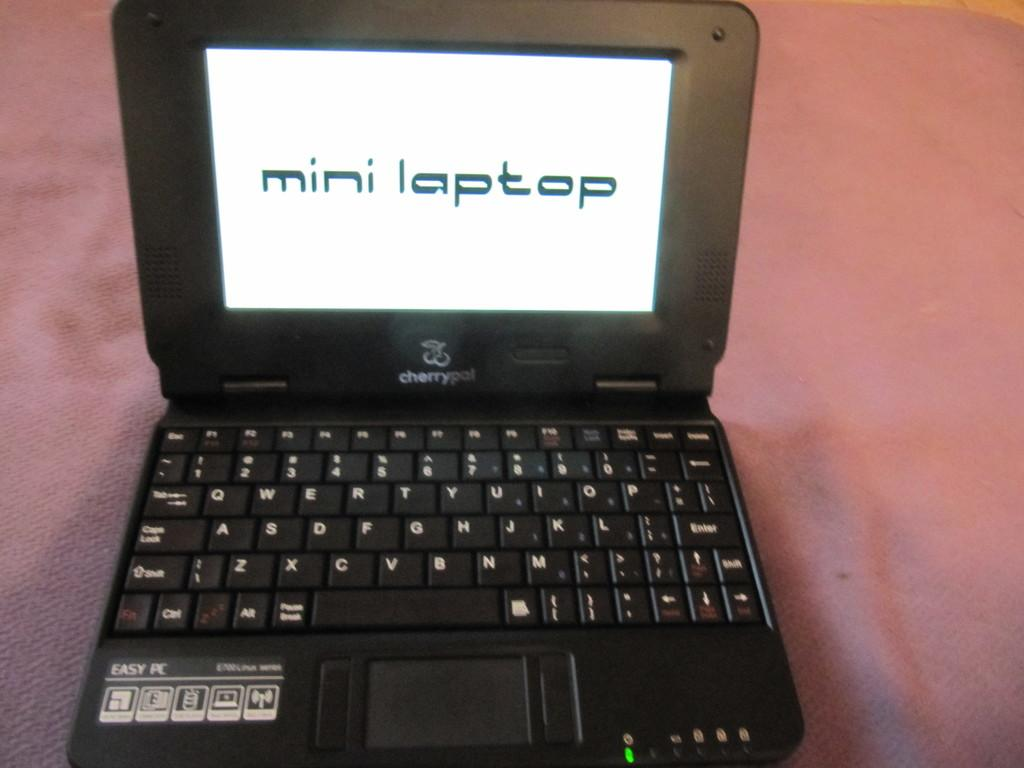<image>
Summarize the visual content of the image. A computer is open to a white screen that simply says mini laptop. 